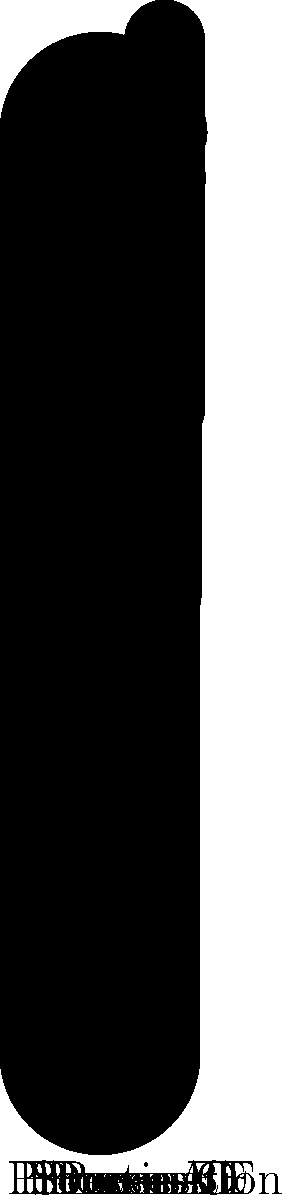In the Sankey diagram representing data flow through various processes, there appears to be an anomaly in the data transmission. Which process is most likely responsible for this anomaly, and what type of security threat might this indicate? To identify the anomaly and potential security threat, let's analyze the data flow step-by-step:

1. Start by examining the flow between each process:
   - Source to Process A: 100 to 90 (10% decrease)
   - Process A to B: 90 to 80 (11.11% decrease)
   - Process B to C: 80 to 70 (12.5% decrease)
   - Process C to D: 70 to 60 (14.29% decrease)
   - Process D to E: 60 to 55 (8.33% decrease)
   - Process E to F: 55 to 45 (18.18% decrease)
   - Process F to Destination: 45 to 40 (11.11% decrease)

2. The largest percentage decrease occurs between Process E and Process F (18.18%).

3. This significant drop in data flow is unusual compared to other transitions, indicating a potential anomaly.

4. In data security, a sudden, unexplained decrease in data volume can indicate:
   - Data exfiltration: unauthorized data being copied or transferred out of the system
   - Data corruption: data being damaged or lost during processing
   - Malicious data manipulation: data being altered or deleted by an attacker

5. Given the context of data security, the most likely threat this anomaly indicates is data exfiltration.

6. Process E is the most likely responsible for this anomaly, as it's the starting point of the unusual data flow decrease.
Answer: Process E; potential data exfiltration 